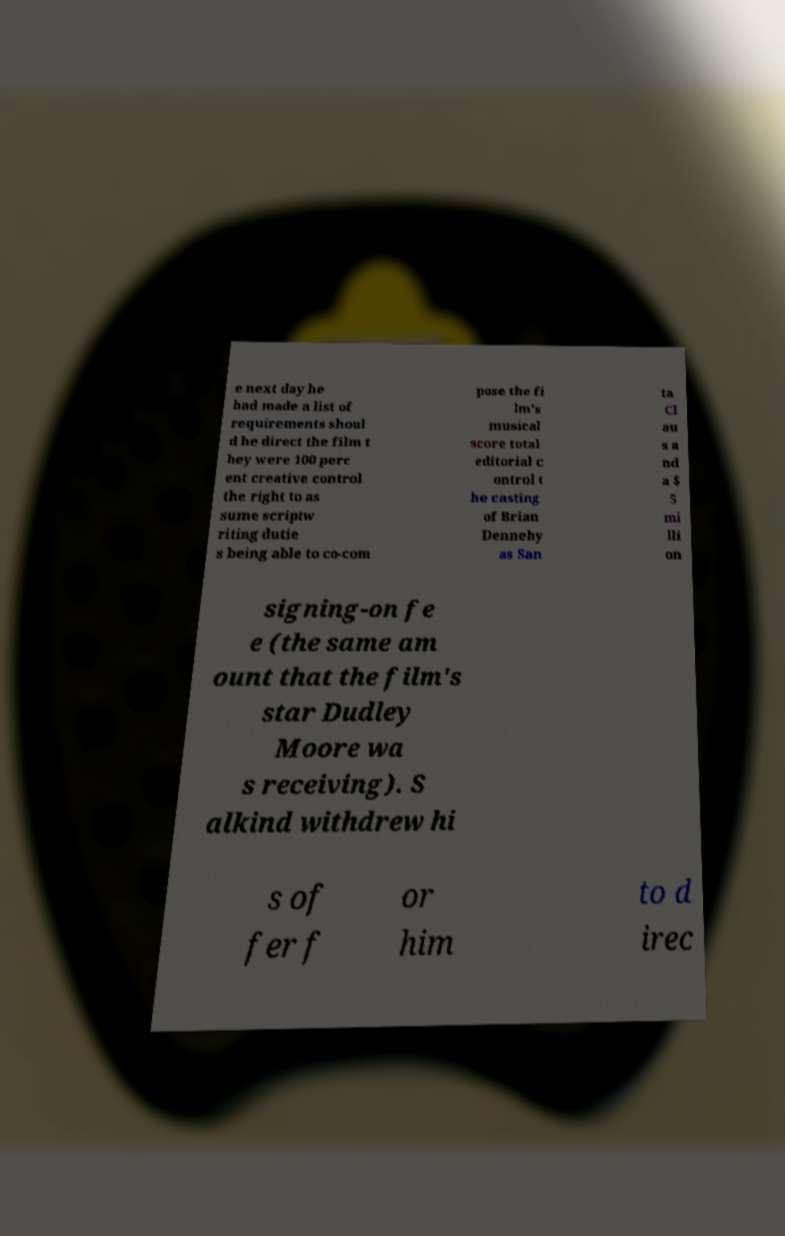Can you accurately transcribe the text from the provided image for me? e next day he had made a list of requirements shoul d he direct the film t hey were 100 perc ent creative control the right to as sume scriptw riting dutie s being able to co-com pose the fi lm's musical score total editorial c ontrol t he casting of Brian Dennehy as San ta Cl au s a nd a $ 5 mi lli on signing-on fe e (the same am ount that the film's star Dudley Moore wa s receiving). S alkind withdrew hi s of fer f or him to d irec 